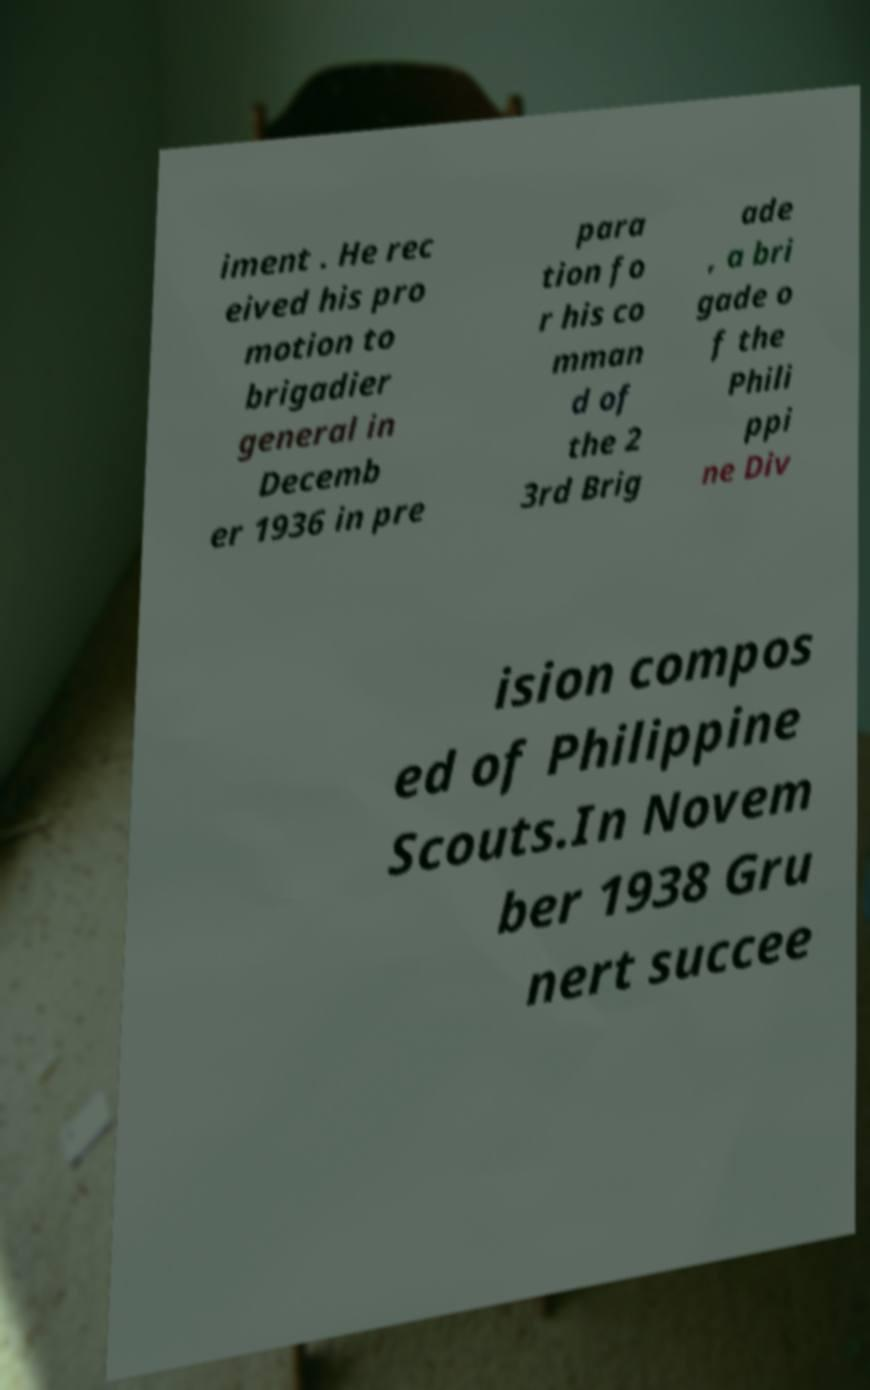Can you accurately transcribe the text from the provided image for me? iment . He rec eived his pro motion to brigadier general in Decemb er 1936 in pre para tion fo r his co mman d of the 2 3rd Brig ade , a bri gade o f the Phili ppi ne Div ision compos ed of Philippine Scouts.In Novem ber 1938 Gru nert succee 